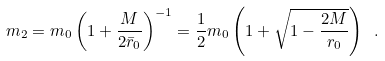Convert formula to latex. <formula><loc_0><loc_0><loc_500><loc_500>m _ { 2 } = m _ { 0 } \left ( 1 + \frac { M } { 2 \bar { r } _ { 0 } } \right ) ^ { - 1 } = { \frac { 1 } { 2 } } m _ { 0 } \left ( 1 + \sqrt { 1 - \frac { 2 M } { r _ { 0 } } } \right ) \ .</formula> 